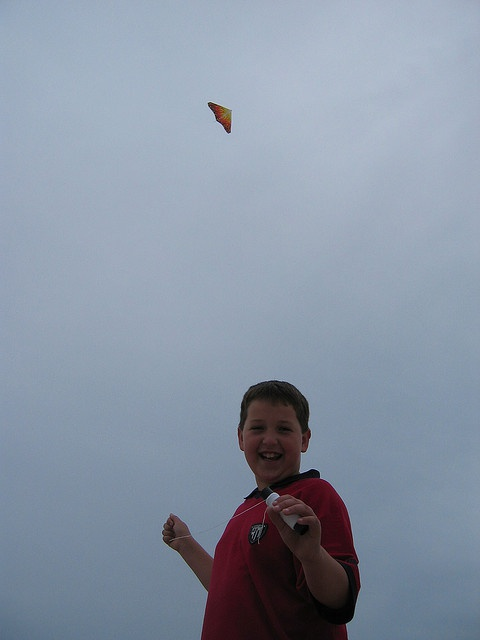Describe the objects in this image and their specific colors. I can see people in darkgray, black, maroon, and gray tones and kite in darkgray, maroon, olive, and brown tones in this image. 